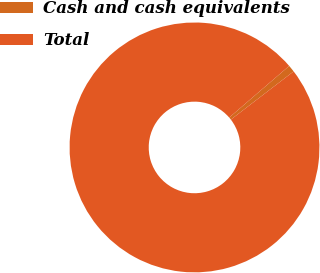Convert chart. <chart><loc_0><loc_0><loc_500><loc_500><pie_chart><fcel>Cash and cash equivalents<fcel>Total<nl><fcel>0.9%<fcel>99.1%<nl></chart> 